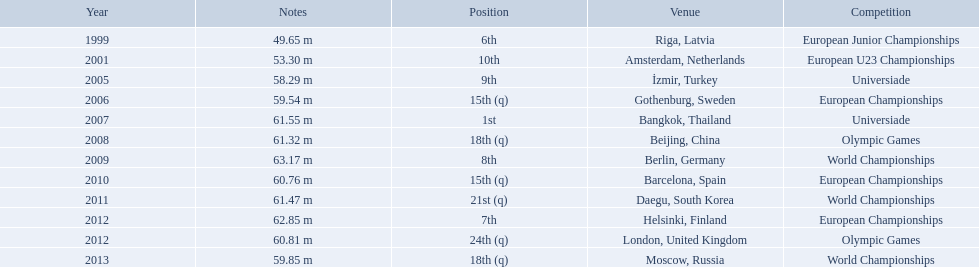What are the years that gerhard mayer participated? 1999, 2001, 2005, 2006, 2007, 2008, 2009, 2010, 2011, 2012, 2012, 2013. Which years were earlier than 2007? 1999, 2001, 2005, 2006. What was the best placing for these years? 6th. 